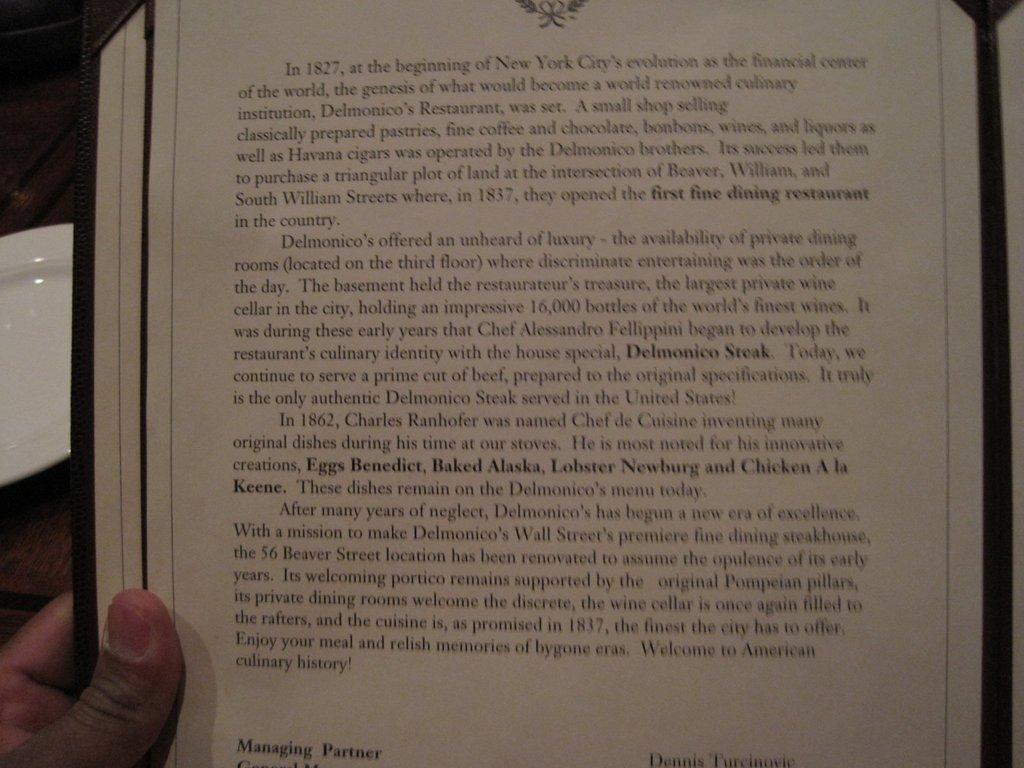Where was delmonico's restaurant located?
Offer a terse response. New york city. 